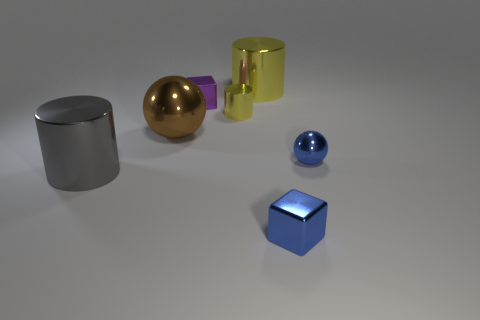Subtract all spheres. How many objects are left? 5 Add 2 small yellow cylinders. How many objects exist? 9 Subtract all yellow shiny cylinders. How many cylinders are left? 1 Subtract 1 cylinders. How many cylinders are left? 2 Subtract all gray cylinders. Subtract all purple blocks. How many cylinders are left? 2 Subtract all green cylinders. How many green spheres are left? 0 Subtract all yellow metallic things. Subtract all blue shiny cubes. How many objects are left? 4 Add 5 gray metal cylinders. How many gray metal cylinders are left? 6 Add 1 cyan metal blocks. How many cyan metal blocks exist? 1 Subtract all brown spheres. How many spheres are left? 1 